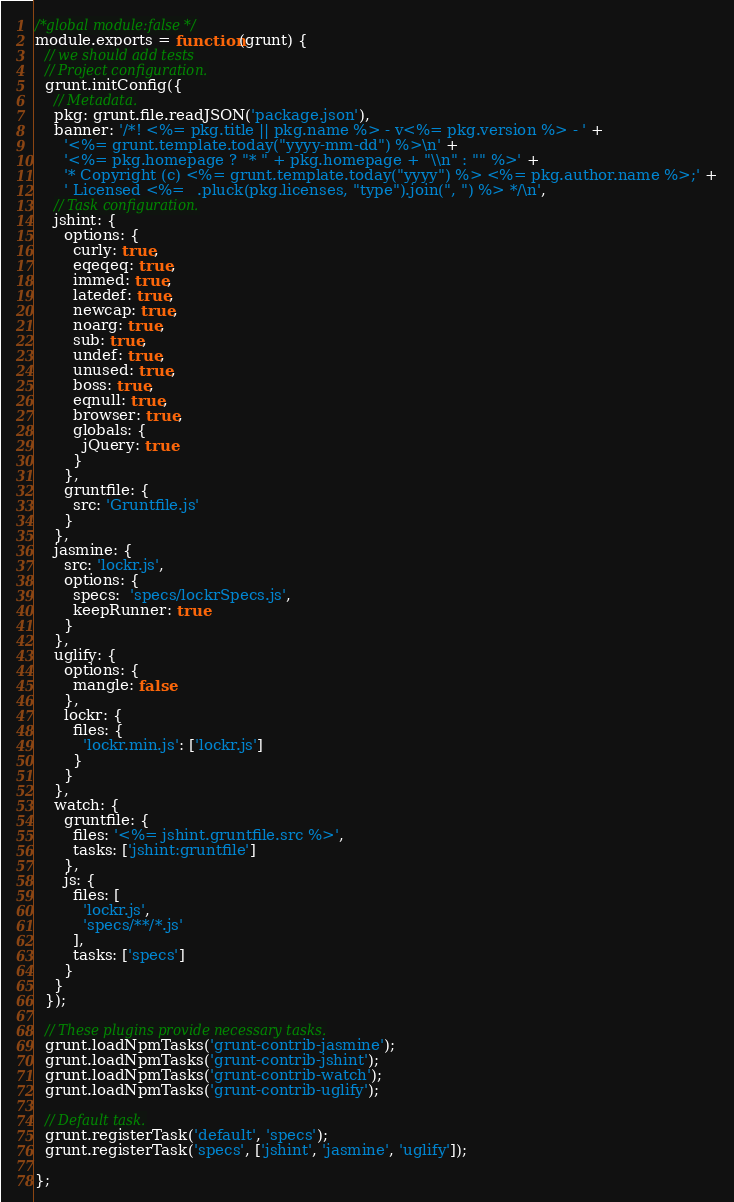<code> <loc_0><loc_0><loc_500><loc_500><_JavaScript_>/*global module:false */
module.exports = function(grunt) {
  // we should add tests
  // Project configuration.
  grunt.initConfig({
    // Metadata.
    pkg: grunt.file.readJSON('package.json'),
    banner: '/*! <%= pkg.title || pkg.name %> - v<%= pkg.version %> - ' +
      '<%= grunt.template.today("yyyy-mm-dd") %>\n' +
      '<%= pkg.homepage ? "* " + pkg.homepage + "\\n" : "" %>' +
      '* Copyright (c) <%= grunt.template.today("yyyy") %> <%= pkg.author.name %>;' +
      ' Licensed <%= _.pluck(pkg.licenses, "type").join(", ") %> */\n',
    // Task configuration.
    jshint: {
      options: {
        curly: true,
        eqeqeq: true,
        immed: true,
        latedef: true,
        newcap: true,
        noarg: true,
        sub: true,
        undef: true,
        unused: true,
        boss: true,
        eqnull: true,
        browser: true,
        globals: {
          jQuery: true
        }
      },
      gruntfile: {
        src: 'Gruntfile.js'
      }
    },
    jasmine: {
      src: 'lockr.js',
      options: {
        specs:  'specs/lockrSpecs.js',
        keepRunner: true
      }
    },
    uglify: {
      options: {
        mangle: false
      },
      lockr: {
        files: {
          'lockr.min.js': ['lockr.js']
        }
      }
    },
    watch: {
      gruntfile: {
        files: '<%= jshint.gruntfile.src %>',
        tasks: ['jshint:gruntfile']
      },
      js: {
        files: [
          'lockr.js',
          'specs/**/*.js'
        ],
        tasks: ['specs']
      }
    }
  });

  // These plugins provide necessary tasks.
  grunt.loadNpmTasks('grunt-contrib-jasmine');
  grunt.loadNpmTasks('grunt-contrib-jshint');
  grunt.loadNpmTasks('grunt-contrib-watch');
  grunt.loadNpmTasks('grunt-contrib-uglify');

  // Default task.
  grunt.registerTask('default', 'specs');
  grunt.registerTask('specs', ['jshint', 'jasmine', 'uglify']);

};
</code> 